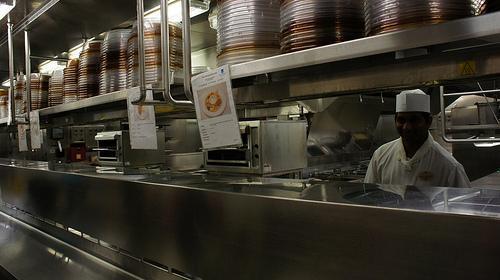How many people are pictured?
Give a very brief answer. 1. How many pieces of paper are shown?
Give a very brief answer. 4. 